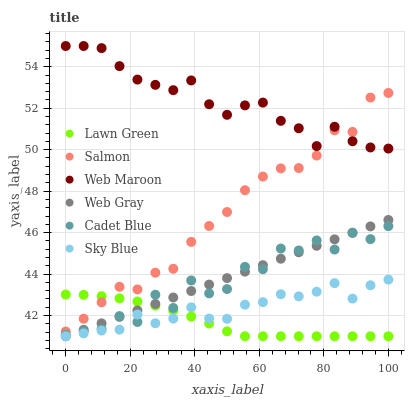Does Lawn Green have the minimum area under the curve?
Answer yes or no. Yes. Does Web Maroon have the maximum area under the curve?
Answer yes or no. Yes. Does Cadet Blue have the minimum area under the curve?
Answer yes or no. No. Does Cadet Blue have the maximum area under the curve?
Answer yes or no. No. Is Web Gray the smoothest?
Answer yes or no. Yes. Is Cadet Blue the roughest?
Answer yes or no. Yes. Is Web Maroon the smoothest?
Answer yes or no. No. Is Web Maroon the roughest?
Answer yes or no. No. Does Lawn Green have the lowest value?
Answer yes or no. Yes. Does Cadet Blue have the lowest value?
Answer yes or no. No. Does Web Maroon have the highest value?
Answer yes or no. Yes. Does Cadet Blue have the highest value?
Answer yes or no. No. Is Web Gray less than Salmon?
Answer yes or no. Yes. Is Salmon greater than Sky Blue?
Answer yes or no. Yes. Does Web Gray intersect Cadet Blue?
Answer yes or no. Yes. Is Web Gray less than Cadet Blue?
Answer yes or no. No. Is Web Gray greater than Cadet Blue?
Answer yes or no. No. Does Web Gray intersect Salmon?
Answer yes or no. No. 